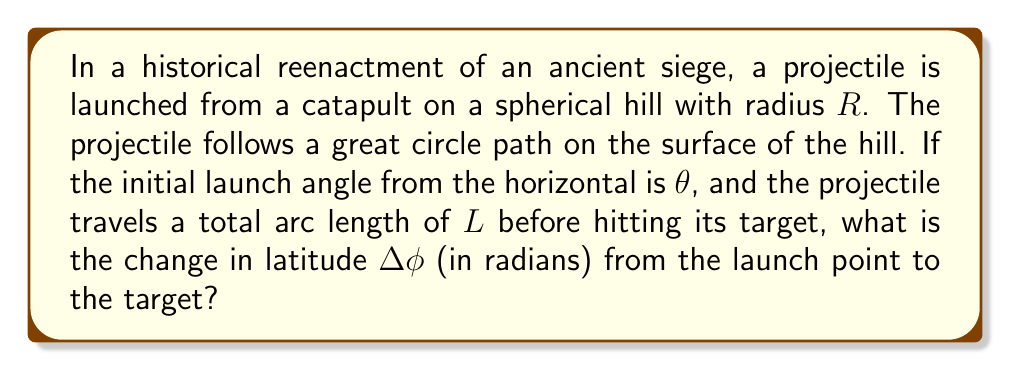Solve this math problem. Let's approach this step-by-step:

1) On a sphere, great circles are geodesics, which represent the shortest path between two points on the surface.

2) The arc length $L$ of a great circle on a sphere of radius $R$ is related to the central angle $\alpha$ by:

   $$L = R\alpha$$

3) We can rearrange this to find the central angle:

   $$\alpha = \frac{L}{R}$$

4) In spherical coordinates, the latitude $\phi$ is measured from the equator to the poles. The change in latitude $\Delta\phi$ is related to the central angle $\alpha$ and the initial launch angle $\theta$ by:

   $$\Delta\phi = \alpha \cos\theta$$

5) This is because the cosine of the launch angle gives us the component of the trajectory in the north-south direction.

6) Substituting our expression for $\alpha$ from step 3:

   $$\Delta\phi = \frac{L}{R} \cos\theta$$

This gives us the change in latitude in radians.
Answer: $\Delta\phi = \frac{L}{R} \cos\theta$ 